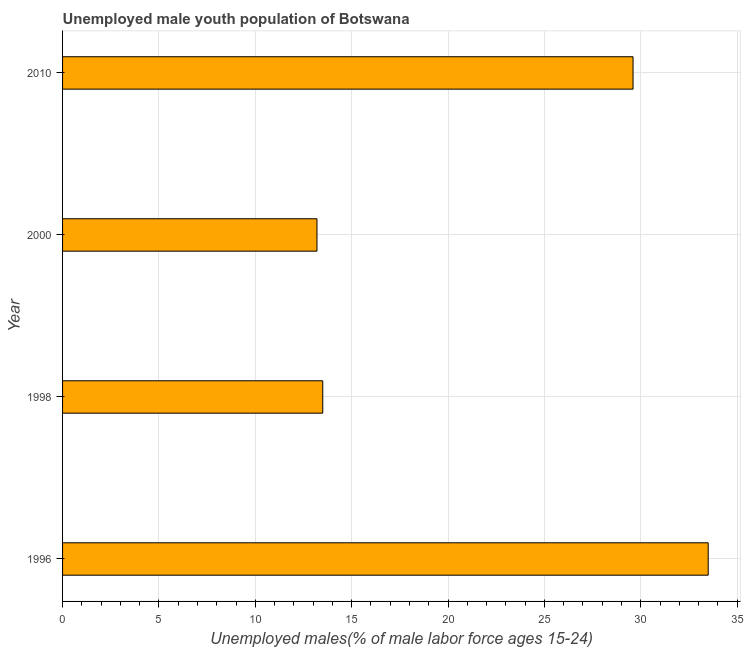What is the title of the graph?
Make the answer very short. Unemployed male youth population of Botswana. What is the label or title of the X-axis?
Make the answer very short. Unemployed males(% of male labor force ages 15-24). What is the label or title of the Y-axis?
Offer a terse response. Year. What is the unemployed male youth in 1996?
Your answer should be compact. 33.5. Across all years, what is the maximum unemployed male youth?
Your answer should be compact. 33.5. Across all years, what is the minimum unemployed male youth?
Your response must be concise. 13.2. In which year was the unemployed male youth maximum?
Provide a short and direct response. 1996. In which year was the unemployed male youth minimum?
Offer a terse response. 2000. What is the sum of the unemployed male youth?
Your response must be concise. 89.8. What is the difference between the unemployed male youth in 1998 and 2010?
Provide a succinct answer. -16.1. What is the average unemployed male youth per year?
Offer a very short reply. 22.45. What is the median unemployed male youth?
Your response must be concise. 21.55. Do a majority of the years between 1998 and 2000 (inclusive) have unemployed male youth greater than 29 %?
Make the answer very short. No. What is the ratio of the unemployed male youth in 1996 to that in 2010?
Make the answer very short. 1.13. Is the unemployed male youth in 2000 less than that in 2010?
Your answer should be very brief. Yes. Is the difference between the unemployed male youth in 1996 and 2000 greater than the difference between any two years?
Your answer should be very brief. Yes. What is the difference between the highest and the lowest unemployed male youth?
Give a very brief answer. 20.3. How many bars are there?
Ensure brevity in your answer.  4. Are all the bars in the graph horizontal?
Make the answer very short. Yes. What is the Unemployed males(% of male labor force ages 15-24) in 1996?
Provide a short and direct response. 33.5. What is the Unemployed males(% of male labor force ages 15-24) of 1998?
Give a very brief answer. 13.5. What is the Unemployed males(% of male labor force ages 15-24) of 2000?
Provide a short and direct response. 13.2. What is the Unemployed males(% of male labor force ages 15-24) in 2010?
Make the answer very short. 29.6. What is the difference between the Unemployed males(% of male labor force ages 15-24) in 1996 and 1998?
Provide a succinct answer. 20. What is the difference between the Unemployed males(% of male labor force ages 15-24) in 1996 and 2000?
Offer a very short reply. 20.3. What is the difference between the Unemployed males(% of male labor force ages 15-24) in 1996 and 2010?
Give a very brief answer. 3.9. What is the difference between the Unemployed males(% of male labor force ages 15-24) in 1998 and 2010?
Offer a terse response. -16.1. What is the difference between the Unemployed males(% of male labor force ages 15-24) in 2000 and 2010?
Your answer should be very brief. -16.4. What is the ratio of the Unemployed males(% of male labor force ages 15-24) in 1996 to that in 1998?
Your answer should be very brief. 2.48. What is the ratio of the Unemployed males(% of male labor force ages 15-24) in 1996 to that in 2000?
Offer a terse response. 2.54. What is the ratio of the Unemployed males(% of male labor force ages 15-24) in 1996 to that in 2010?
Give a very brief answer. 1.13. What is the ratio of the Unemployed males(% of male labor force ages 15-24) in 1998 to that in 2010?
Your answer should be very brief. 0.46. What is the ratio of the Unemployed males(% of male labor force ages 15-24) in 2000 to that in 2010?
Your response must be concise. 0.45. 